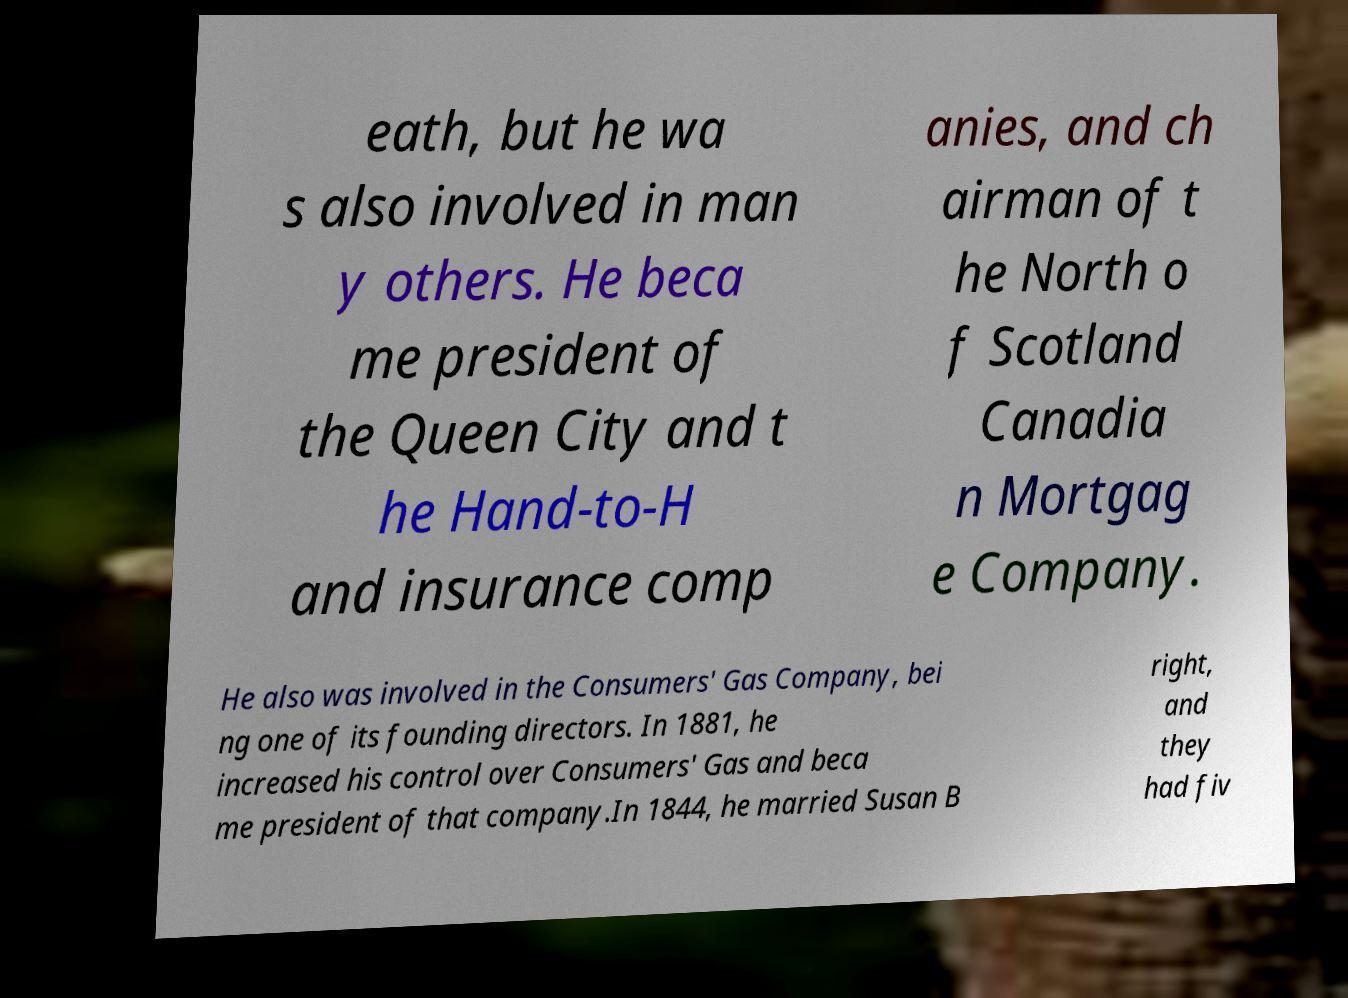Could you assist in decoding the text presented in this image and type it out clearly? eath, but he wa s also involved in man y others. He beca me president of the Queen City and t he Hand-to-H and insurance comp anies, and ch airman of t he North o f Scotland Canadia n Mortgag e Company. He also was involved in the Consumers' Gas Company, bei ng one of its founding directors. In 1881, he increased his control over Consumers' Gas and beca me president of that company.In 1844, he married Susan B right, and they had fiv 